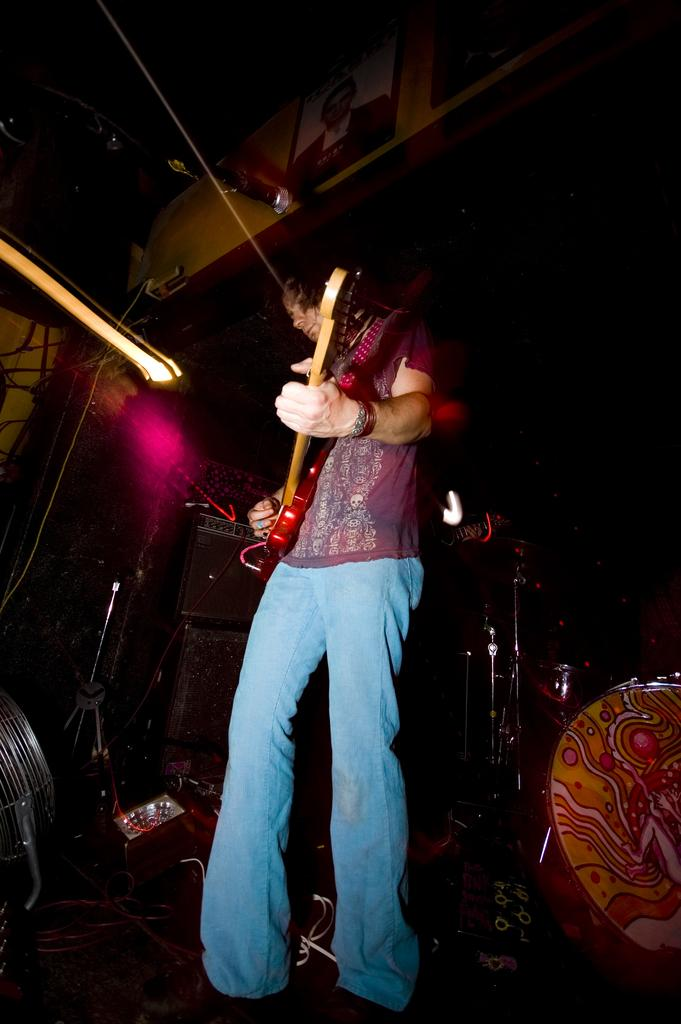What is the man in the image doing? The man is playing a guitar in the image. What other musical instruments can be seen in the image? There is a drum and other musical instruments in the background of the image. Can you describe the lighting in the image? There is a light in the image. What type of structure is present in the image? There is a frame in the image. What type of powder is being used by the bear in the image? There is no bear present in the image, and therefore no powder can be observed. Can you describe the swing that the man is using in the image? There is no swing present in the image; the man is playing a guitar while standing. 